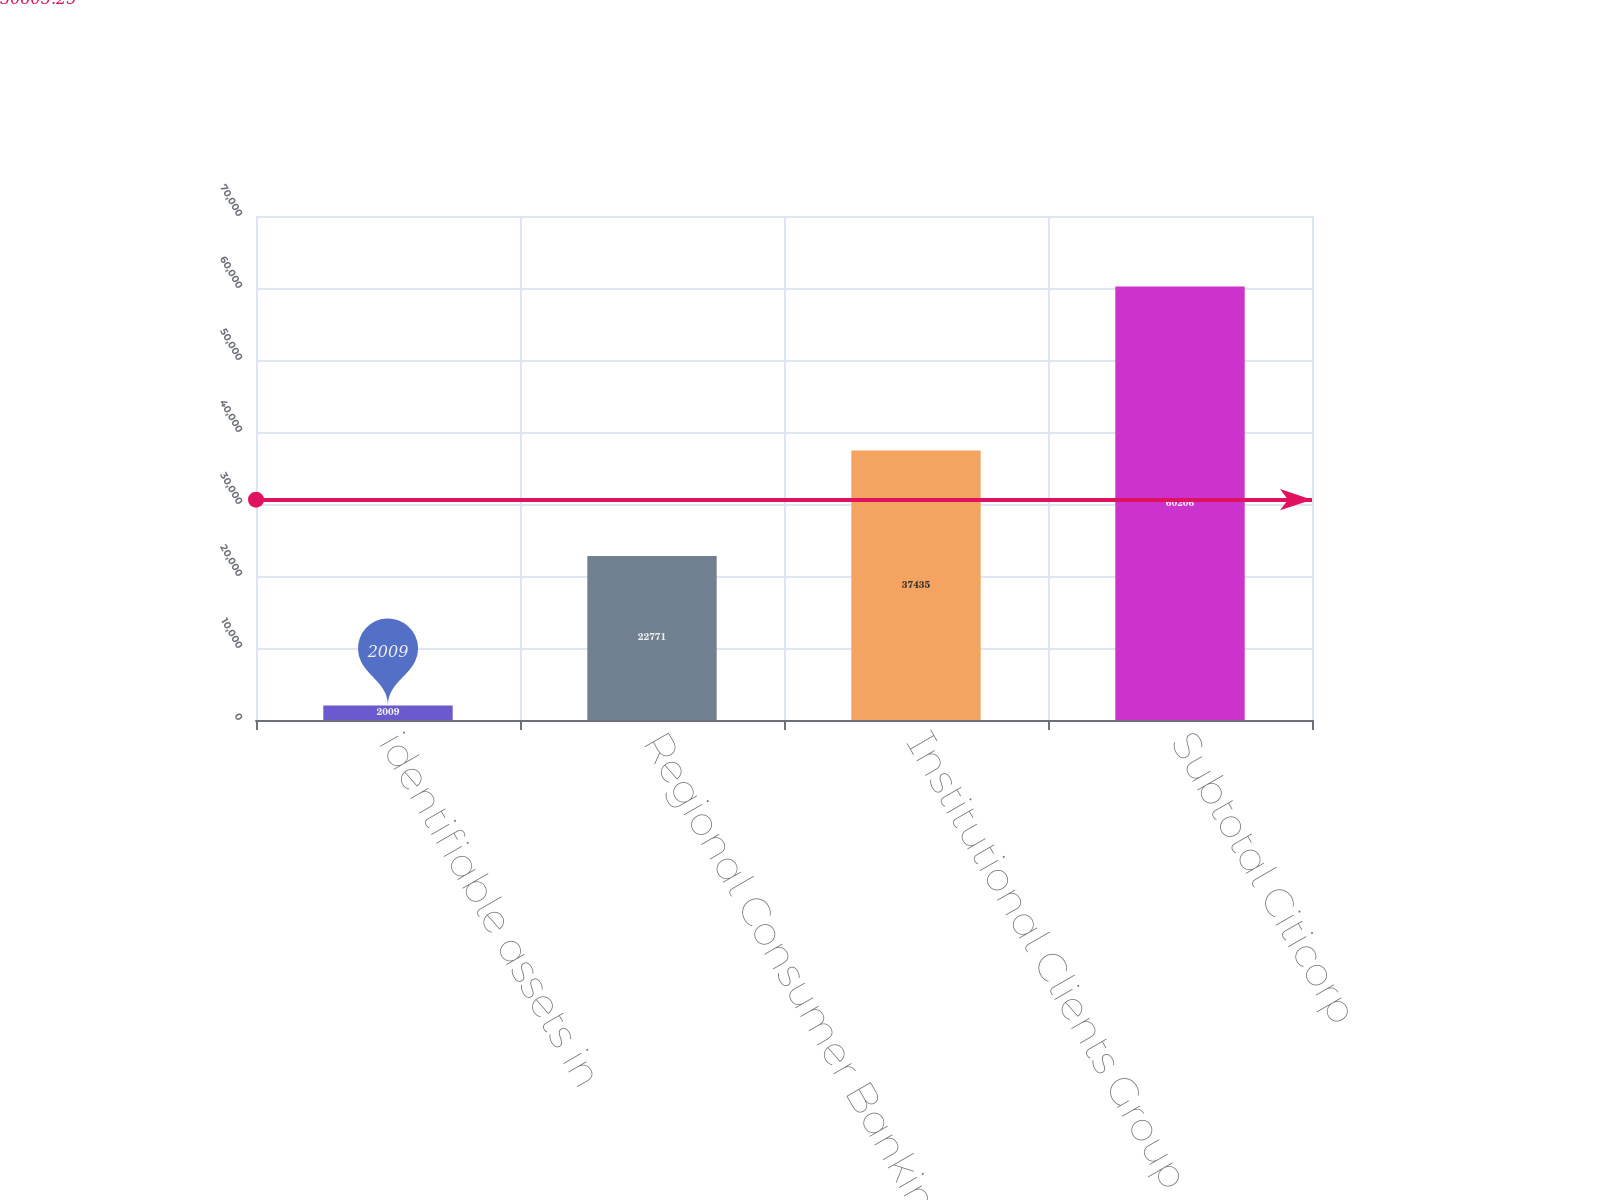<chart> <loc_0><loc_0><loc_500><loc_500><bar_chart><fcel>identifiable assets in<fcel>Regional Consumer Banking<fcel>Institutional Clients Group<fcel>Subtotal Citicorp<nl><fcel>2009<fcel>22771<fcel>37435<fcel>60206<nl></chart> 